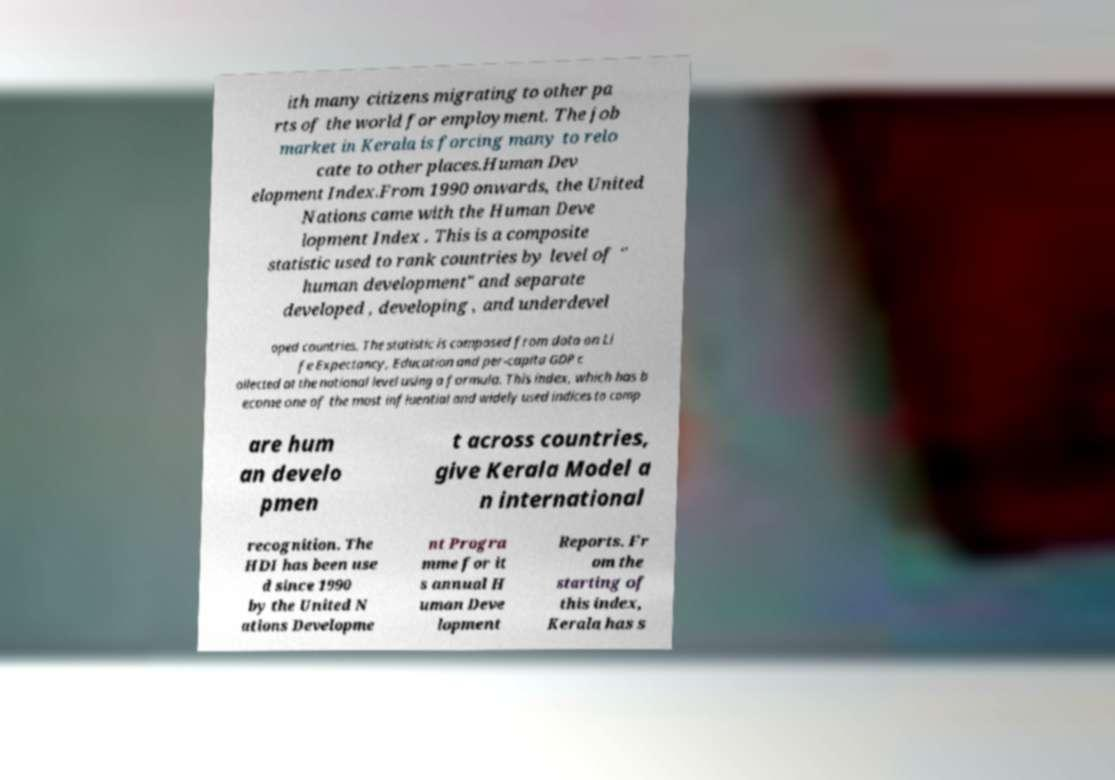For documentation purposes, I need the text within this image transcribed. Could you provide that? ith many citizens migrating to other pa rts of the world for employment. The job market in Kerala is forcing many to relo cate to other places.Human Dev elopment Index.From 1990 onwards, the United Nations came with the Human Deve lopment Index . This is a composite statistic used to rank countries by level of " human development" and separate developed , developing , and underdevel oped countries. The statistic is composed from data on Li fe Expectancy, Education and per-capita GDP c ollected at the national level using a formula. This index, which has b ecome one of the most influential and widely used indices to comp are hum an develo pmen t across countries, give Kerala Model a n international recognition. The HDI has been use d since 1990 by the United N ations Developme nt Progra mme for it s annual H uman Deve lopment Reports. Fr om the starting of this index, Kerala has s 